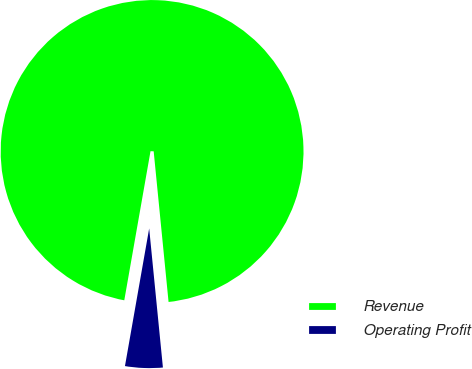Convert chart to OTSL. <chart><loc_0><loc_0><loc_500><loc_500><pie_chart><fcel>Revenue<fcel>Operating Profit<nl><fcel>95.66%<fcel>4.34%<nl></chart> 